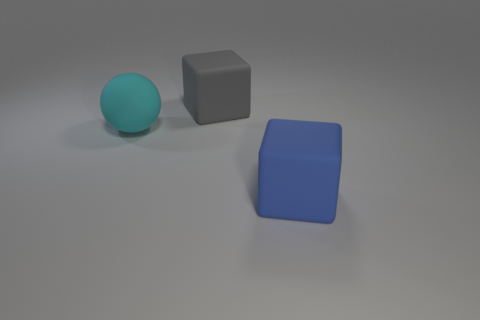Are there fewer big spheres that are right of the big gray matte cube than small gray objects?
Your response must be concise. No. What number of other cyan balls are made of the same material as the big cyan ball?
Your response must be concise. 0. What color is the large sphere that is the same material as the big blue thing?
Make the answer very short. Cyan. What is the shape of the big blue object?
Give a very brief answer. Cube. What is the material of the cube that is on the right side of the big gray rubber cube?
Your answer should be very brief. Rubber. There is a blue object that is the same size as the gray rubber cube; what shape is it?
Provide a succinct answer. Cube. There is a matte block to the left of the blue cube; what color is it?
Provide a short and direct response. Gray. Are there any large cyan matte objects that are in front of the block in front of the ball?
Ensure brevity in your answer.  No. What number of objects are either big cyan objects that are on the left side of the blue object or large brown objects?
Provide a succinct answer. 1. Are there any other things that are the same size as the ball?
Ensure brevity in your answer.  Yes. 